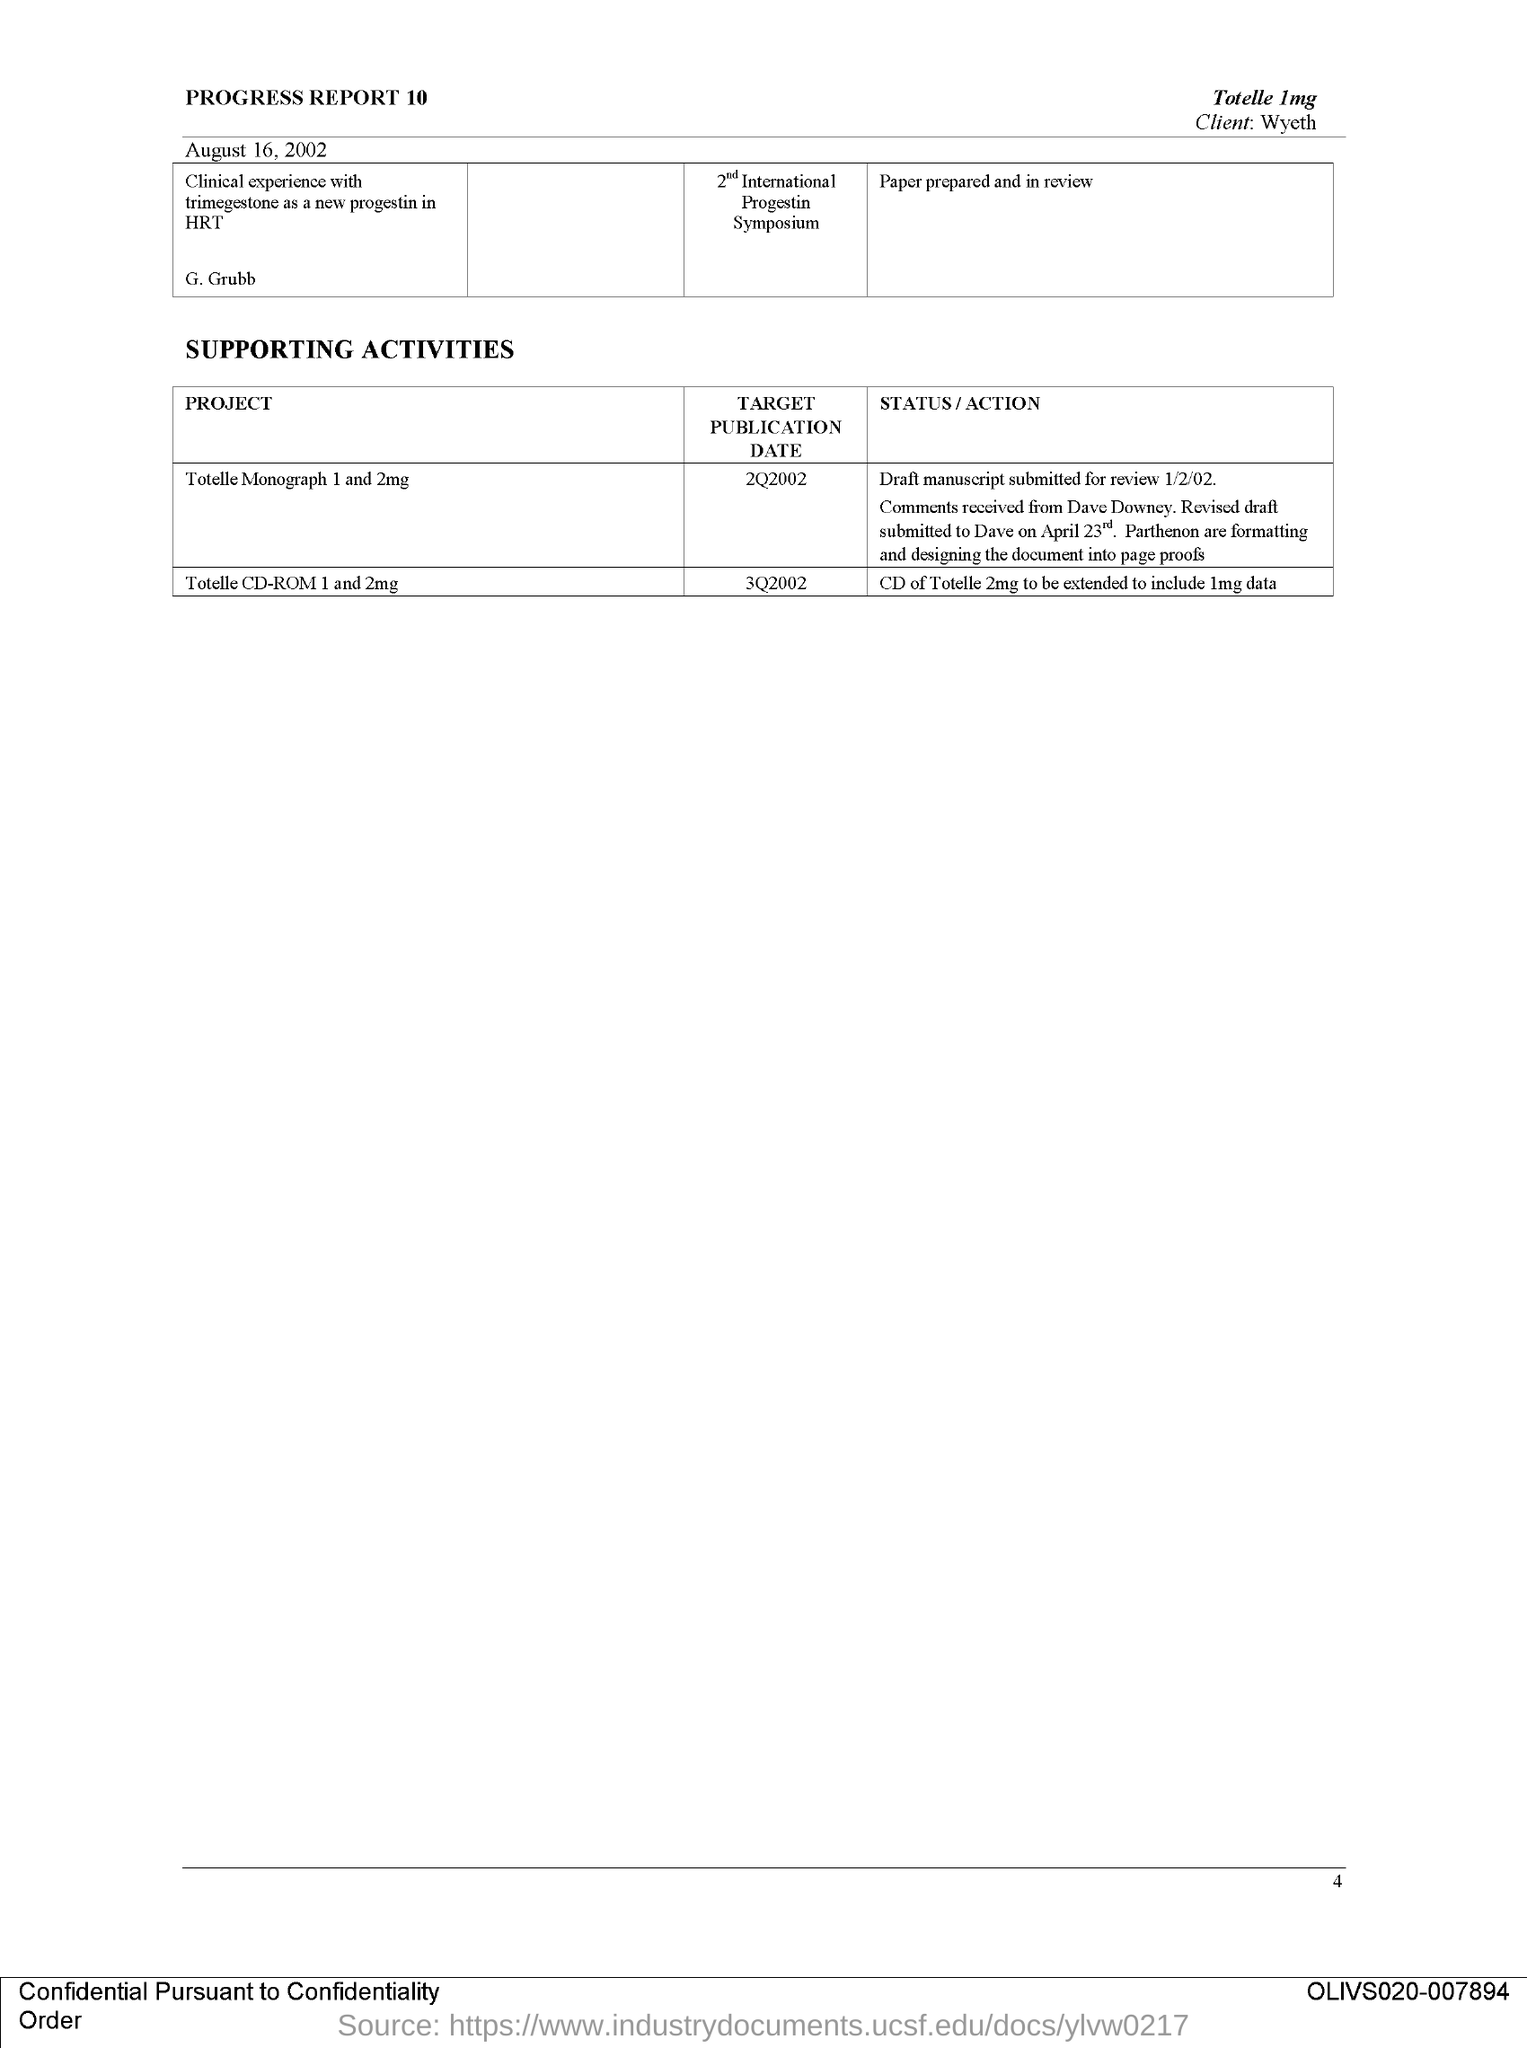What is the Target Publication Date of the Project "Totelle Monograph 1 and 2mg"?
Offer a very short reply. 2Q2002. Which Project has the target Publication date as 3Q2002?
Provide a short and direct response. Totelle CD-ROM 1 and 2mg. What is the Status/Action of the project "Totelle CD-ROM 1 and 2mg"?
Your response must be concise. CD of Totelle 2mg to be extended to include 1mg data. Who is the client as per the document?
Make the answer very short. Wyeth. When was this document dated?
Keep it short and to the point. August 16, 2002. What is the page no mentioned in this document?
Your response must be concise. 4. 